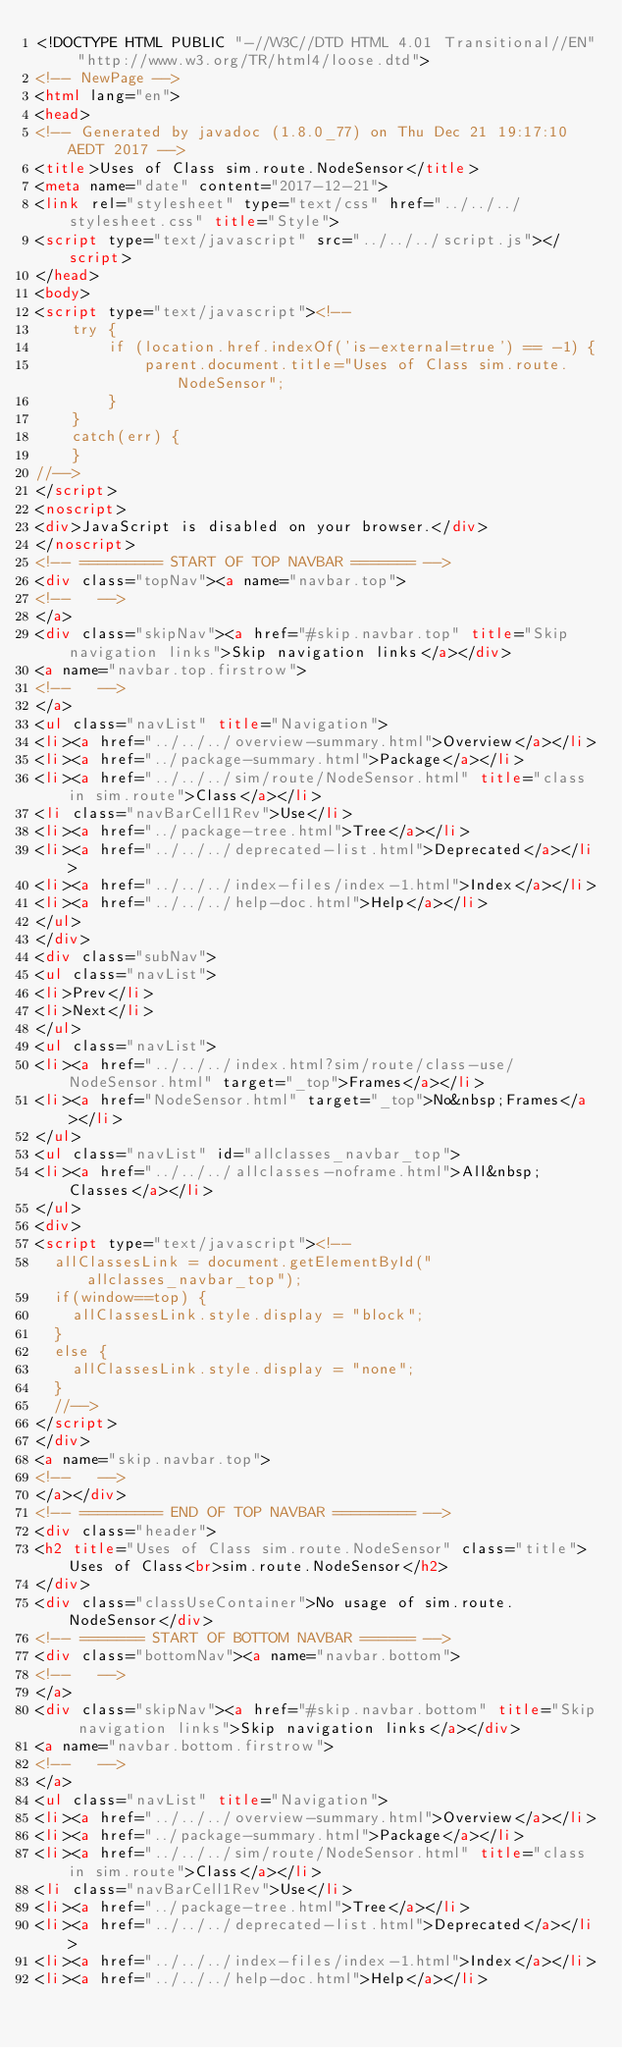Convert code to text. <code><loc_0><loc_0><loc_500><loc_500><_HTML_><!DOCTYPE HTML PUBLIC "-//W3C//DTD HTML 4.01 Transitional//EN" "http://www.w3.org/TR/html4/loose.dtd">
<!-- NewPage -->
<html lang="en">
<head>
<!-- Generated by javadoc (1.8.0_77) on Thu Dec 21 19:17:10 AEDT 2017 -->
<title>Uses of Class sim.route.NodeSensor</title>
<meta name="date" content="2017-12-21">
<link rel="stylesheet" type="text/css" href="../../../stylesheet.css" title="Style">
<script type="text/javascript" src="../../../script.js"></script>
</head>
<body>
<script type="text/javascript"><!--
    try {
        if (location.href.indexOf('is-external=true') == -1) {
            parent.document.title="Uses of Class sim.route.NodeSensor";
        }
    }
    catch(err) {
    }
//-->
</script>
<noscript>
<div>JavaScript is disabled on your browser.</div>
</noscript>
<!-- ========= START OF TOP NAVBAR ======= -->
<div class="topNav"><a name="navbar.top">
<!--   -->
</a>
<div class="skipNav"><a href="#skip.navbar.top" title="Skip navigation links">Skip navigation links</a></div>
<a name="navbar.top.firstrow">
<!--   -->
</a>
<ul class="navList" title="Navigation">
<li><a href="../../../overview-summary.html">Overview</a></li>
<li><a href="../package-summary.html">Package</a></li>
<li><a href="../../../sim/route/NodeSensor.html" title="class in sim.route">Class</a></li>
<li class="navBarCell1Rev">Use</li>
<li><a href="../package-tree.html">Tree</a></li>
<li><a href="../../../deprecated-list.html">Deprecated</a></li>
<li><a href="../../../index-files/index-1.html">Index</a></li>
<li><a href="../../../help-doc.html">Help</a></li>
</ul>
</div>
<div class="subNav">
<ul class="navList">
<li>Prev</li>
<li>Next</li>
</ul>
<ul class="navList">
<li><a href="../../../index.html?sim/route/class-use/NodeSensor.html" target="_top">Frames</a></li>
<li><a href="NodeSensor.html" target="_top">No&nbsp;Frames</a></li>
</ul>
<ul class="navList" id="allclasses_navbar_top">
<li><a href="../../../allclasses-noframe.html">All&nbsp;Classes</a></li>
</ul>
<div>
<script type="text/javascript"><!--
  allClassesLink = document.getElementById("allclasses_navbar_top");
  if(window==top) {
    allClassesLink.style.display = "block";
  }
  else {
    allClassesLink.style.display = "none";
  }
  //-->
</script>
</div>
<a name="skip.navbar.top">
<!--   -->
</a></div>
<!-- ========= END OF TOP NAVBAR ========= -->
<div class="header">
<h2 title="Uses of Class sim.route.NodeSensor" class="title">Uses of Class<br>sim.route.NodeSensor</h2>
</div>
<div class="classUseContainer">No usage of sim.route.NodeSensor</div>
<!-- ======= START OF BOTTOM NAVBAR ====== -->
<div class="bottomNav"><a name="navbar.bottom">
<!--   -->
</a>
<div class="skipNav"><a href="#skip.navbar.bottom" title="Skip navigation links">Skip navigation links</a></div>
<a name="navbar.bottom.firstrow">
<!--   -->
</a>
<ul class="navList" title="Navigation">
<li><a href="../../../overview-summary.html">Overview</a></li>
<li><a href="../package-summary.html">Package</a></li>
<li><a href="../../../sim/route/NodeSensor.html" title="class in sim.route">Class</a></li>
<li class="navBarCell1Rev">Use</li>
<li><a href="../package-tree.html">Tree</a></li>
<li><a href="../../../deprecated-list.html">Deprecated</a></li>
<li><a href="../../../index-files/index-1.html">Index</a></li>
<li><a href="../../../help-doc.html">Help</a></li></code> 